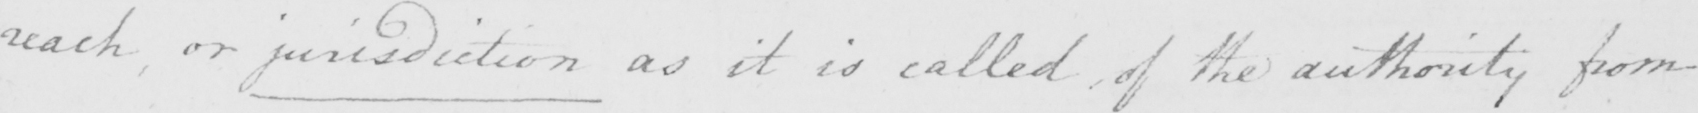Please provide the text content of this handwritten line. reach or jurisdiction as it is called  , of the authority from 